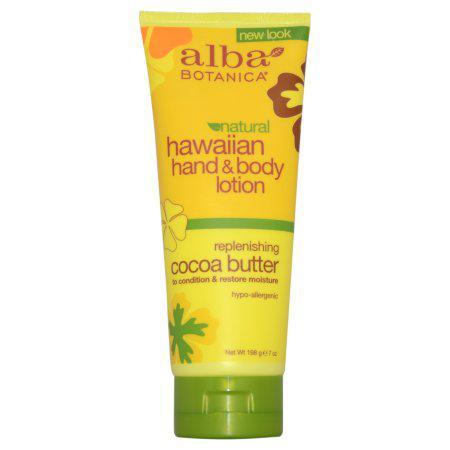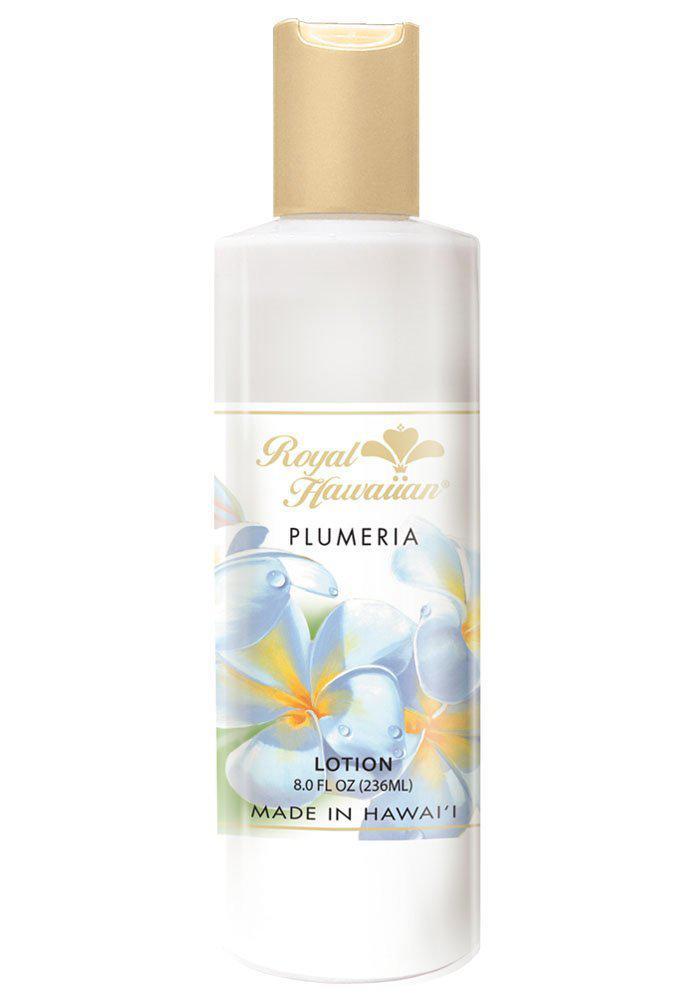The first image is the image on the left, the second image is the image on the right. Assess this claim about the two images: "There is a single bottle in one of the images, and in the other image there are more than three other bottles.". Correct or not? Answer yes or no. No. The first image is the image on the left, the second image is the image on the right. Assess this claim about the two images: "An image shows one tube-type skincare product standing upright on its green cap.". Correct or not? Answer yes or no. Yes. 